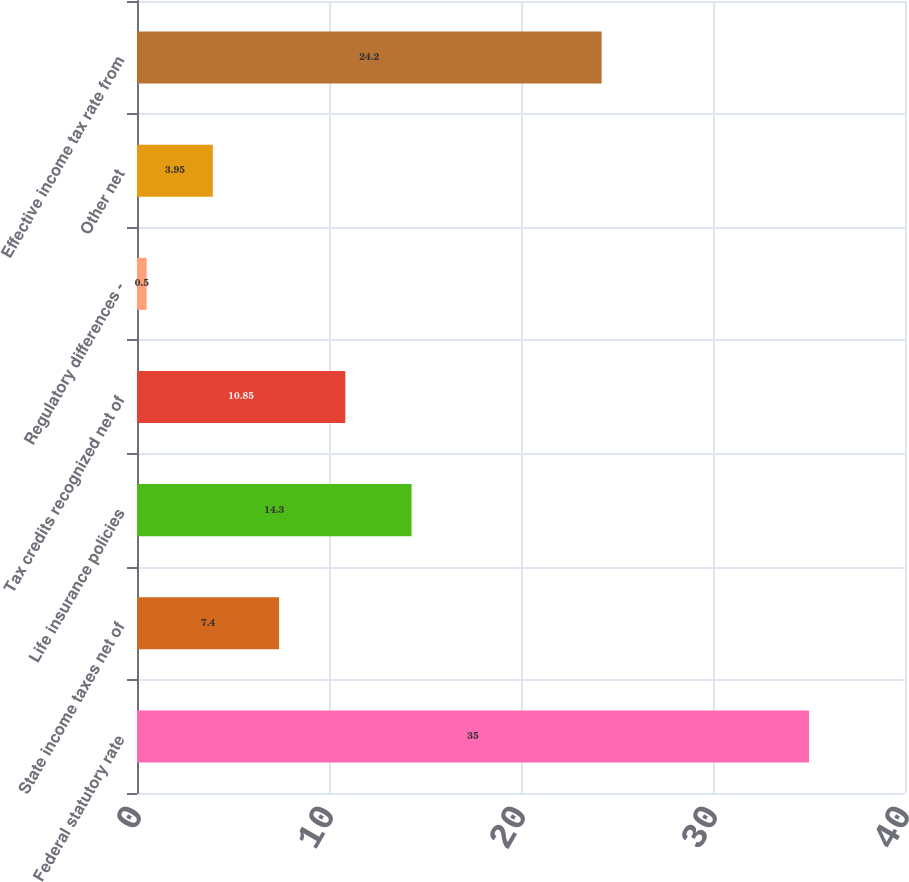<chart> <loc_0><loc_0><loc_500><loc_500><bar_chart><fcel>Federal statutory rate<fcel>State income taxes net of<fcel>Life insurance policies<fcel>Tax credits recognized net of<fcel>Regulatory differences -<fcel>Other net<fcel>Effective income tax rate from<nl><fcel>35<fcel>7.4<fcel>14.3<fcel>10.85<fcel>0.5<fcel>3.95<fcel>24.2<nl></chart> 